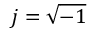Convert formula to latex. <formula><loc_0><loc_0><loc_500><loc_500>j = \sqrt { - 1 }</formula> 